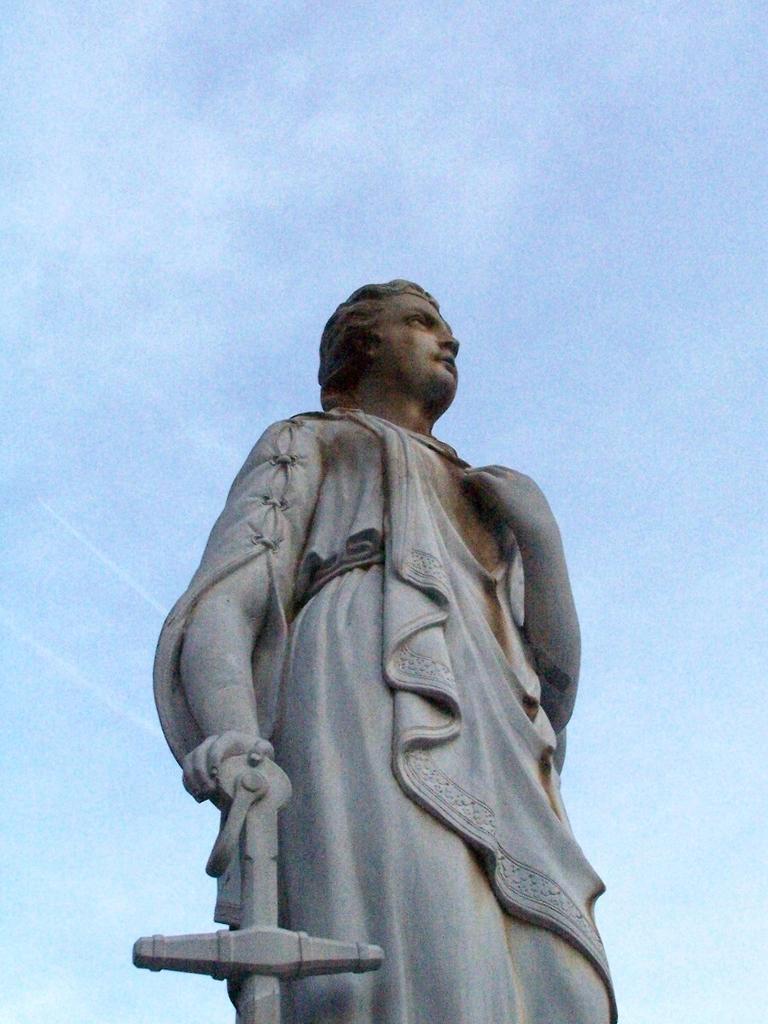Could you give a brief overview of what you see in this image? In this image, we can see a statue and we can see the sky. 